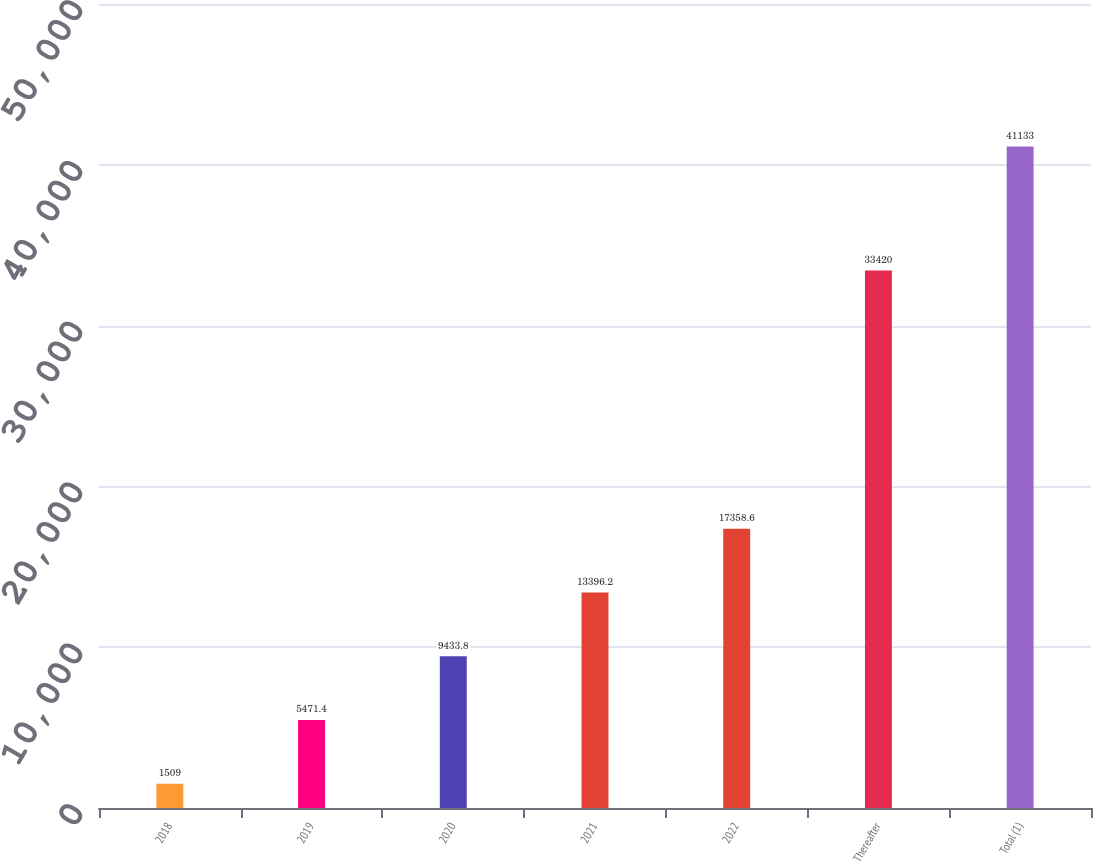<chart> <loc_0><loc_0><loc_500><loc_500><bar_chart><fcel>2018<fcel>2019<fcel>2020<fcel>2021<fcel>2022<fcel>Thereafter<fcel>Total (1)<nl><fcel>1509<fcel>5471.4<fcel>9433.8<fcel>13396.2<fcel>17358.6<fcel>33420<fcel>41133<nl></chart> 